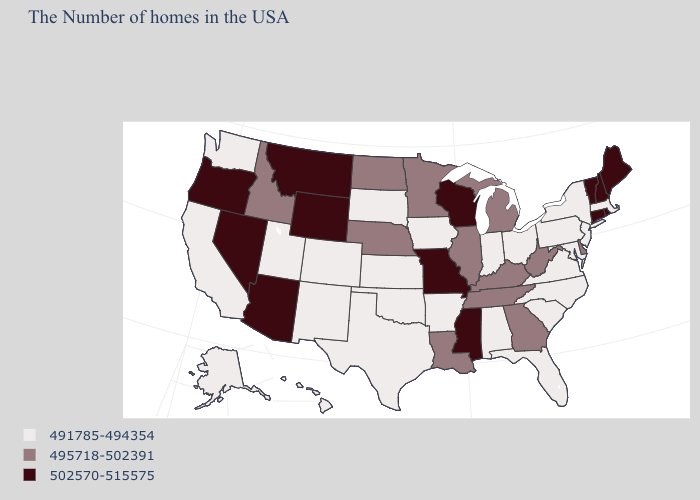What is the value of Colorado?
Write a very short answer. 491785-494354. Which states hav the highest value in the South?
Short answer required. Mississippi. What is the lowest value in the West?
Concise answer only. 491785-494354. Name the states that have a value in the range 491785-494354?
Write a very short answer. Massachusetts, New York, New Jersey, Maryland, Pennsylvania, Virginia, North Carolina, South Carolina, Ohio, Florida, Indiana, Alabama, Arkansas, Iowa, Kansas, Oklahoma, Texas, South Dakota, Colorado, New Mexico, Utah, California, Washington, Alaska, Hawaii. What is the value of Pennsylvania?
Write a very short answer. 491785-494354. Name the states that have a value in the range 502570-515575?
Give a very brief answer. Maine, Rhode Island, New Hampshire, Vermont, Connecticut, Wisconsin, Mississippi, Missouri, Wyoming, Montana, Arizona, Nevada, Oregon. What is the lowest value in the MidWest?
Be succinct. 491785-494354. Does Tennessee have a lower value than Kentucky?
Keep it brief. No. How many symbols are there in the legend?
Keep it brief. 3. Name the states that have a value in the range 491785-494354?
Be succinct. Massachusetts, New York, New Jersey, Maryland, Pennsylvania, Virginia, North Carolina, South Carolina, Ohio, Florida, Indiana, Alabama, Arkansas, Iowa, Kansas, Oklahoma, Texas, South Dakota, Colorado, New Mexico, Utah, California, Washington, Alaska, Hawaii. How many symbols are there in the legend?
Write a very short answer. 3. Name the states that have a value in the range 491785-494354?
Be succinct. Massachusetts, New York, New Jersey, Maryland, Pennsylvania, Virginia, North Carolina, South Carolina, Ohio, Florida, Indiana, Alabama, Arkansas, Iowa, Kansas, Oklahoma, Texas, South Dakota, Colorado, New Mexico, Utah, California, Washington, Alaska, Hawaii. What is the lowest value in the USA?
Answer briefly. 491785-494354. Does Missouri have the highest value in the USA?
Write a very short answer. Yes. What is the lowest value in states that border Maine?
Concise answer only. 502570-515575. 